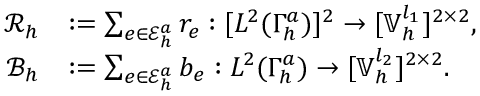<formula> <loc_0><loc_0><loc_500><loc_500>\begin{array} { r l } { \mathcal { R } _ { h } } & { \colon = \sum _ { e \in \mathcal { E } _ { h } ^ { a } } r _ { e } \colon [ L ^ { 2 } ( \Gamma _ { h } ^ { a } ) ] ^ { 2 } \rightarrow [ \mathbb { V } _ { h } ^ { l _ { 1 } } ] ^ { 2 \times 2 } , } \\ { \mathcal { B } _ { h } } & { \colon = \sum _ { e \in \mathcal { E } _ { h } ^ { a } } b _ { e } \colon L ^ { 2 } ( \Gamma _ { h } ^ { a } ) \rightarrow [ \mathbb { V } _ { h } ^ { l _ { 2 } } ] ^ { 2 \times 2 } . } \end{array}</formula> 